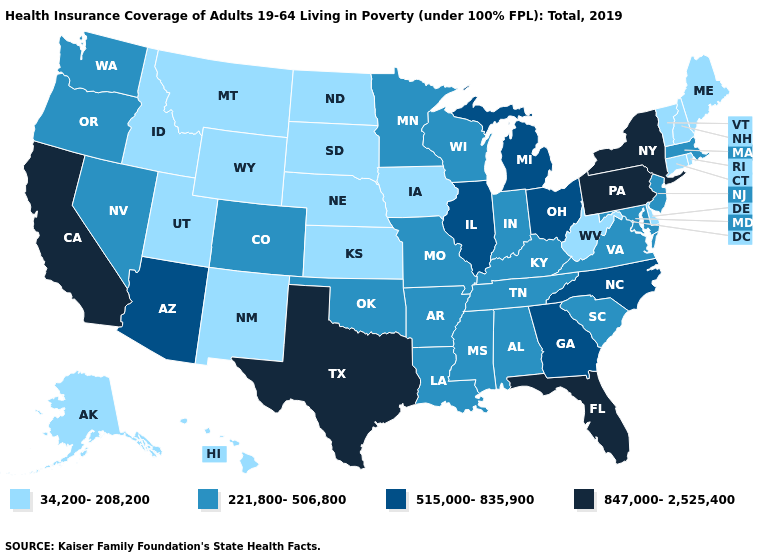Name the states that have a value in the range 34,200-208,200?
Quick response, please. Alaska, Connecticut, Delaware, Hawaii, Idaho, Iowa, Kansas, Maine, Montana, Nebraska, New Hampshire, New Mexico, North Dakota, Rhode Island, South Dakota, Utah, Vermont, West Virginia, Wyoming. What is the highest value in states that border Wisconsin?
Keep it brief. 515,000-835,900. Which states have the lowest value in the USA?
Give a very brief answer. Alaska, Connecticut, Delaware, Hawaii, Idaho, Iowa, Kansas, Maine, Montana, Nebraska, New Hampshire, New Mexico, North Dakota, Rhode Island, South Dakota, Utah, Vermont, West Virginia, Wyoming. Does Delaware have the lowest value in the South?
Answer briefly. Yes. Among the states that border Iowa , which have the highest value?
Be succinct. Illinois. Among the states that border Utah , which have the lowest value?
Be succinct. Idaho, New Mexico, Wyoming. What is the value of Mississippi?
Quick response, please. 221,800-506,800. What is the value of Oregon?
Quick response, please. 221,800-506,800. Does Colorado have a higher value than Kentucky?
Short answer required. No. Name the states that have a value in the range 221,800-506,800?
Concise answer only. Alabama, Arkansas, Colorado, Indiana, Kentucky, Louisiana, Maryland, Massachusetts, Minnesota, Mississippi, Missouri, Nevada, New Jersey, Oklahoma, Oregon, South Carolina, Tennessee, Virginia, Washington, Wisconsin. What is the value of Connecticut?
Give a very brief answer. 34,200-208,200. What is the lowest value in the USA?
Concise answer only. 34,200-208,200. Which states have the highest value in the USA?
Write a very short answer. California, Florida, New York, Pennsylvania, Texas. Among the states that border Virginia , does North Carolina have the highest value?
Answer briefly. Yes. Name the states that have a value in the range 515,000-835,900?
Give a very brief answer. Arizona, Georgia, Illinois, Michigan, North Carolina, Ohio. 